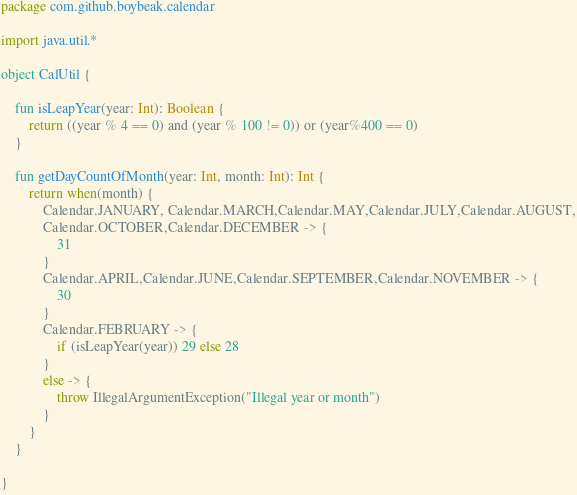Convert code to text. <code><loc_0><loc_0><loc_500><loc_500><_Kotlin_>package com.github.boybeak.calendar

import java.util.*

object CalUtil {

    fun isLeapYear(year: Int): Boolean {
        return ((year % 4 == 0) and (year % 100 != 0)) or (year%400 == 0)
    }

    fun getDayCountOfMonth(year: Int, month: Int): Int {
        return when(month) {
            Calendar.JANUARY, Calendar.MARCH,Calendar.MAY,Calendar.JULY,Calendar.AUGUST,
            Calendar.OCTOBER,Calendar.DECEMBER -> {
                31
            }
            Calendar.APRIL,Calendar.JUNE,Calendar.SEPTEMBER,Calendar.NOVEMBER -> {
                30
            }
            Calendar.FEBRUARY -> {
                if (isLeapYear(year)) 29 else 28
            }
            else -> {
                throw IllegalArgumentException("Illegal year or month")
            }
        }
    }

}</code> 